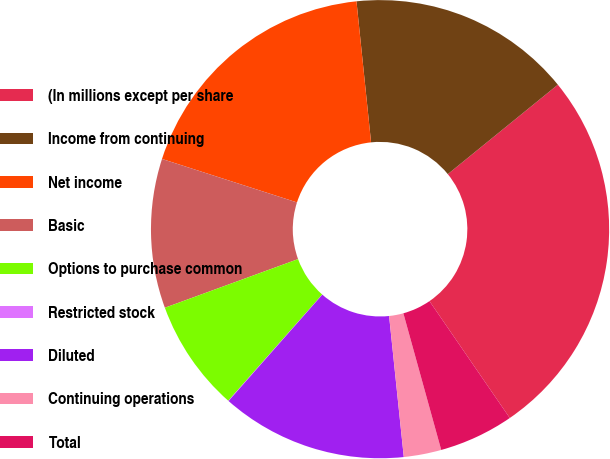<chart> <loc_0><loc_0><loc_500><loc_500><pie_chart><fcel>(In millions except per share<fcel>Income from continuing<fcel>Net income<fcel>Basic<fcel>Options to purchase common<fcel>Restricted stock<fcel>Diluted<fcel>Continuing operations<fcel>Total<nl><fcel>26.28%<fcel>15.78%<fcel>18.4%<fcel>10.53%<fcel>7.9%<fcel>0.03%<fcel>13.15%<fcel>2.65%<fcel>5.28%<nl></chart> 